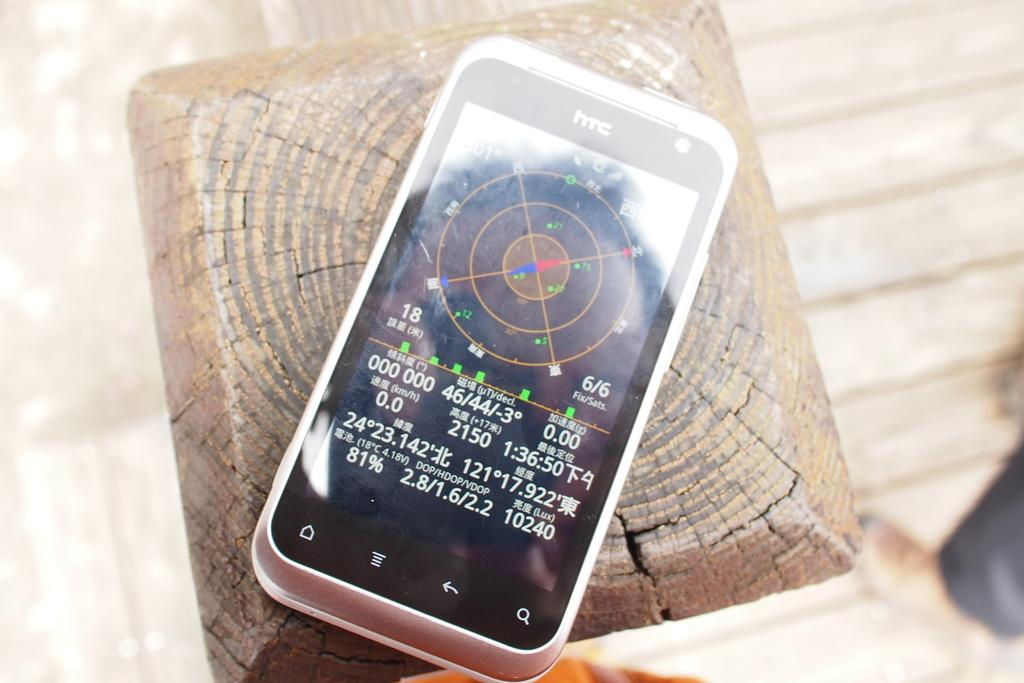<image>
Describe the image concisely. An HTC phone is on a wooden post and has a compass displayed. 